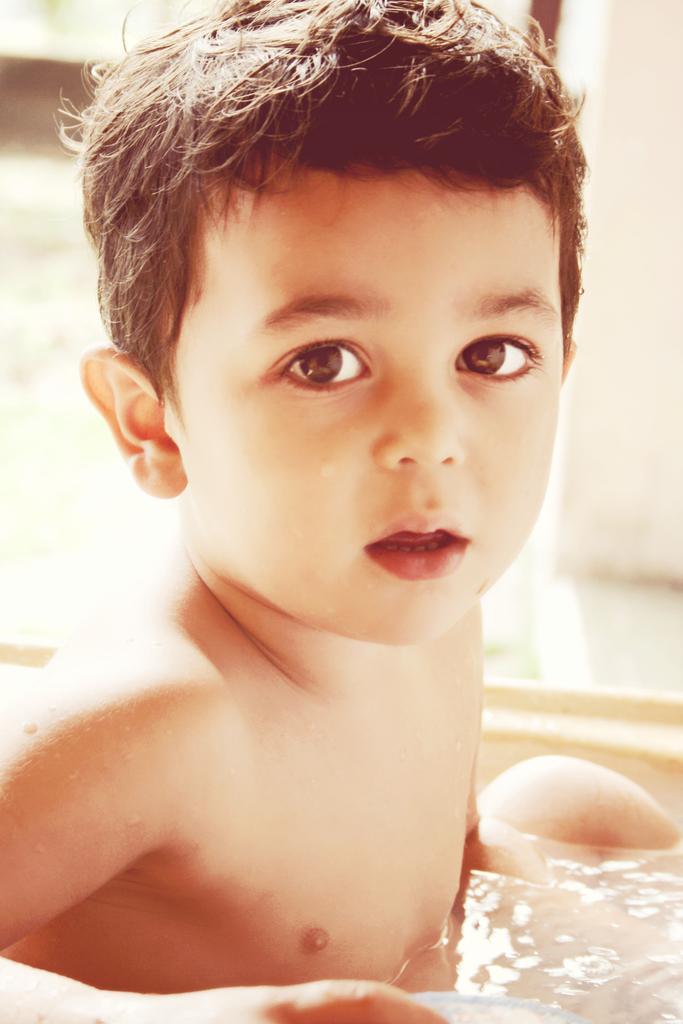Please provide a concise description of this image. This picture shows a boy in the water tub. 